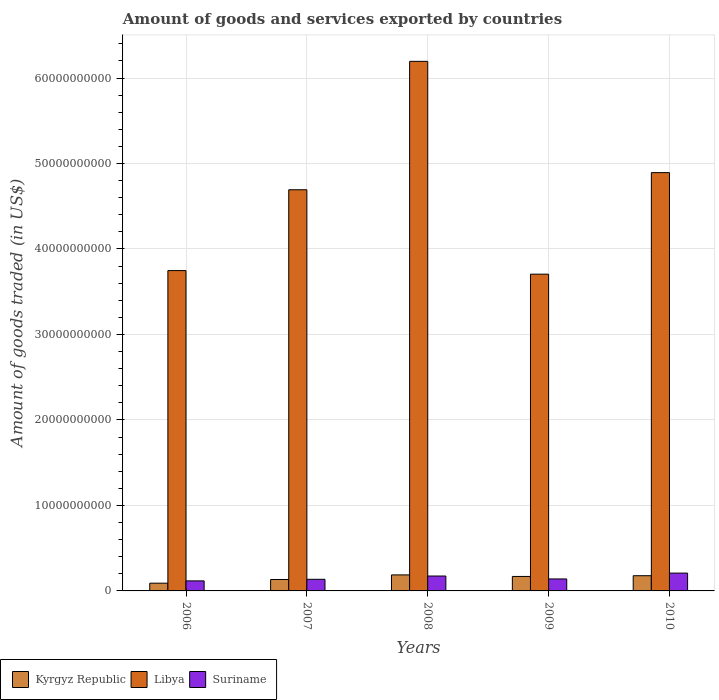How many different coloured bars are there?
Offer a terse response. 3. How many bars are there on the 5th tick from the left?
Make the answer very short. 3. How many bars are there on the 1st tick from the right?
Offer a very short reply. 3. What is the total amount of goods and services exported in Kyrgyz Republic in 2009?
Ensure brevity in your answer.  1.69e+09. Across all years, what is the maximum total amount of goods and services exported in Kyrgyz Republic?
Your answer should be very brief. 1.87e+09. Across all years, what is the minimum total amount of goods and services exported in Suriname?
Your answer should be compact. 1.17e+09. In which year was the total amount of goods and services exported in Suriname maximum?
Provide a succinct answer. 2010. In which year was the total amount of goods and services exported in Kyrgyz Republic minimum?
Make the answer very short. 2006. What is the total total amount of goods and services exported in Libya in the graph?
Make the answer very short. 2.32e+11. What is the difference between the total amount of goods and services exported in Kyrgyz Republic in 2006 and that in 2009?
Give a very brief answer. -7.88e+08. What is the difference between the total amount of goods and services exported in Libya in 2008 and the total amount of goods and services exported in Suriname in 2010?
Your answer should be very brief. 5.99e+1. What is the average total amount of goods and services exported in Kyrgyz Republic per year?
Your answer should be compact. 1.52e+09. In the year 2009, what is the difference between the total amount of goods and services exported in Kyrgyz Republic and total amount of goods and services exported in Suriname?
Keep it short and to the point. 2.92e+08. What is the ratio of the total amount of goods and services exported in Kyrgyz Republic in 2006 to that in 2007?
Offer a terse response. 0.68. Is the difference between the total amount of goods and services exported in Kyrgyz Republic in 2008 and 2010 greater than the difference between the total amount of goods and services exported in Suriname in 2008 and 2010?
Make the answer very short. Yes. What is the difference between the highest and the second highest total amount of goods and services exported in Kyrgyz Republic?
Your answer should be compact. 9.57e+07. What is the difference between the highest and the lowest total amount of goods and services exported in Suriname?
Give a very brief answer. 9.10e+08. In how many years, is the total amount of goods and services exported in Kyrgyz Republic greater than the average total amount of goods and services exported in Kyrgyz Republic taken over all years?
Offer a terse response. 3. What does the 3rd bar from the left in 2008 represents?
Give a very brief answer. Suriname. What does the 1st bar from the right in 2006 represents?
Offer a very short reply. Suriname. Is it the case that in every year, the sum of the total amount of goods and services exported in Libya and total amount of goods and services exported in Kyrgyz Republic is greater than the total amount of goods and services exported in Suriname?
Your response must be concise. Yes. How many bars are there?
Ensure brevity in your answer.  15. Are all the bars in the graph horizontal?
Make the answer very short. No. What is the difference between two consecutive major ticks on the Y-axis?
Your answer should be very brief. 1.00e+1. Are the values on the major ticks of Y-axis written in scientific E-notation?
Ensure brevity in your answer.  No. Does the graph contain any zero values?
Your response must be concise. No. Does the graph contain grids?
Provide a succinct answer. Yes. Where does the legend appear in the graph?
Your response must be concise. Bottom left. How many legend labels are there?
Provide a short and direct response. 3. How are the legend labels stacked?
Provide a short and direct response. Horizontal. What is the title of the graph?
Your answer should be compact. Amount of goods and services exported by countries. What is the label or title of the Y-axis?
Your answer should be compact. Amount of goods traded (in US$). What is the Amount of goods traded (in US$) of Kyrgyz Republic in 2006?
Offer a terse response. 9.06e+08. What is the Amount of goods traded (in US$) in Libya in 2006?
Offer a terse response. 3.75e+1. What is the Amount of goods traded (in US$) in Suriname in 2006?
Make the answer very short. 1.17e+09. What is the Amount of goods traded (in US$) in Kyrgyz Republic in 2007?
Give a very brief answer. 1.34e+09. What is the Amount of goods traded (in US$) in Libya in 2007?
Your response must be concise. 4.69e+1. What is the Amount of goods traded (in US$) of Suriname in 2007?
Provide a short and direct response. 1.36e+09. What is the Amount of goods traded (in US$) of Kyrgyz Republic in 2008?
Keep it short and to the point. 1.87e+09. What is the Amount of goods traded (in US$) of Libya in 2008?
Your answer should be very brief. 6.20e+1. What is the Amount of goods traded (in US$) of Suriname in 2008?
Your answer should be compact. 1.74e+09. What is the Amount of goods traded (in US$) of Kyrgyz Republic in 2009?
Offer a very short reply. 1.69e+09. What is the Amount of goods traded (in US$) in Libya in 2009?
Make the answer very short. 3.71e+1. What is the Amount of goods traded (in US$) in Suriname in 2009?
Offer a very short reply. 1.40e+09. What is the Amount of goods traded (in US$) in Kyrgyz Republic in 2010?
Ensure brevity in your answer.  1.78e+09. What is the Amount of goods traded (in US$) in Libya in 2010?
Your answer should be very brief. 4.89e+1. What is the Amount of goods traded (in US$) in Suriname in 2010?
Provide a succinct answer. 2.08e+09. Across all years, what is the maximum Amount of goods traded (in US$) in Kyrgyz Republic?
Ensure brevity in your answer.  1.87e+09. Across all years, what is the maximum Amount of goods traded (in US$) of Libya?
Give a very brief answer. 6.20e+1. Across all years, what is the maximum Amount of goods traded (in US$) in Suriname?
Provide a short and direct response. 2.08e+09. Across all years, what is the minimum Amount of goods traded (in US$) of Kyrgyz Republic?
Provide a short and direct response. 9.06e+08. Across all years, what is the minimum Amount of goods traded (in US$) in Libya?
Make the answer very short. 3.71e+1. Across all years, what is the minimum Amount of goods traded (in US$) in Suriname?
Provide a short and direct response. 1.17e+09. What is the total Amount of goods traded (in US$) of Kyrgyz Republic in the graph?
Make the answer very short. 7.59e+09. What is the total Amount of goods traded (in US$) of Libya in the graph?
Give a very brief answer. 2.32e+11. What is the total Amount of goods traded (in US$) of Suriname in the graph?
Offer a very short reply. 7.76e+09. What is the difference between the Amount of goods traded (in US$) of Kyrgyz Republic in 2006 and that in 2007?
Offer a terse response. -4.32e+08. What is the difference between the Amount of goods traded (in US$) in Libya in 2006 and that in 2007?
Offer a very short reply. -9.46e+09. What is the difference between the Amount of goods traded (in US$) in Suriname in 2006 and that in 2007?
Provide a short and direct response. -1.84e+08. What is the difference between the Amount of goods traded (in US$) in Kyrgyz Republic in 2006 and that in 2008?
Offer a terse response. -9.68e+08. What is the difference between the Amount of goods traded (in US$) of Libya in 2006 and that in 2008?
Make the answer very short. -2.45e+1. What is the difference between the Amount of goods traded (in US$) of Suriname in 2006 and that in 2008?
Keep it short and to the point. -5.69e+08. What is the difference between the Amount of goods traded (in US$) of Kyrgyz Republic in 2006 and that in 2009?
Your answer should be compact. -7.88e+08. What is the difference between the Amount of goods traded (in US$) of Libya in 2006 and that in 2009?
Your answer should be compact. 4.18e+08. What is the difference between the Amount of goods traded (in US$) of Suriname in 2006 and that in 2009?
Provide a short and direct response. -2.27e+08. What is the difference between the Amount of goods traded (in US$) in Kyrgyz Republic in 2006 and that in 2010?
Your answer should be compact. -8.73e+08. What is the difference between the Amount of goods traded (in US$) of Libya in 2006 and that in 2010?
Give a very brief answer. -1.15e+1. What is the difference between the Amount of goods traded (in US$) in Suriname in 2006 and that in 2010?
Ensure brevity in your answer.  -9.10e+08. What is the difference between the Amount of goods traded (in US$) of Kyrgyz Republic in 2007 and that in 2008?
Offer a very short reply. -5.37e+08. What is the difference between the Amount of goods traded (in US$) in Libya in 2007 and that in 2008?
Offer a very short reply. -1.50e+1. What is the difference between the Amount of goods traded (in US$) of Suriname in 2007 and that in 2008?
Give a very brief answer. -3.84e+08. What is the difference between the Amount of goods traded (in US$) of Kyrgyz Republic in 2007 and that in 2009?
Offer a terse response. -3.56e+08. What is the difference between the Amount of goods traded (in US$) in Libya in 2007 and that in 2009?
Give a very brief answer. 9.87e+09. What is the difference between the Amount of goods traded (in US$) of Suriname in 2007 and that in 2009?
Give a very brief answer. -4.28e+07. What is the difference between the Amount of goods traded (in US$) in Kyrgyz Republic in 2007 and that in 2010?
Offer a terse response. -4.41e+08. What is the difference between the Amount of goods traded (in US$) of Libya in 2007 and that in 2010?
Ensure brevity in your answer.  -2.01e+09. What is the difference between the Amount of goods traded (in US$) of Suriname in 2007 and that in 2010?
Provide a short and direct response. -7.25e+08. What is the difference between the Amount of goods traded (in US$) in Kyrgyz Republic in 2008 and that in 2009?
Make the answer very short. 1.81e+08. What is the difference between the Amount of goods traded (in US$) of Libya in 2008 and that in 2009?
Give a very brief answer. 2.49e+1. What is the difference between the Amount of goods traded (in US$) of Suriname in 2008 and that in 2009?
Your answer should be compact. 3.42e+08. What is the difference between the Amount of goods traded (in US$) of Kyrgyz Republic in 2008 and that in 2010?
Provide a short and direct response. 9.57e+07. What is the difference between the Amount of goods traded (in US$) in Libya in 2008 and that in 2010?
Offer a very short reply. 1.30e+1. What is the difference between the Amount of goods traded (in US$) of Suriname in 2008 and that in 2010?
Your answer should be very brief. -3.41e+08. What is the difference between the Amount of goods traded (in US$) in Kyrgyz Republic in 2009 and that in 2010?
Provide a short and direct response. -8.49e+07. What is the difference between the Amount of goods traded (in US$) of Libya in 2009 and that in 2010?
Provide a succinct answer. -1.19e+1. What is the difference between the Amount of goods traded (in US$) in Suriname in 2009 and that in 2010?
Provide a succinct answer. -6.82e+08. What is the difference between the Amount of goods traded (in US$) in Kyrgyz Republic in 2006 and the Amount of goods traded (in US$) in Libya in 2007?
Make the answer very short. -4.60e+1. What is the difference between the Amount of goods traded (in US$) of Kyrgyz Republic in 2006 and the Amount of goods traded (in US$) of Suriname in 2007?
Make the answer very short. -4.53e+08. What is the difference between the Amount of goods traded (in US$) of Libya in 2006 and the Amount of goods traded (in US$) of Suriname in 2007?
Provide a succinct answer. 3.61e+1. What is the difference between the Amount of goods traded (in US$) of Kyrgyz Republic in 2006 and the Amount of goods traded (in US$) of Libya in 2008?
Ensure brevity in your answer.  -6.10e+1. What is the difference between the Amount of goods traded (in US$) of Kyrgyz Republic in 2006 and the Amount of goods traded (in US$) of Suriname in 2008?
Provide a short and direct response. -8.38e+08. What is the difference between the Amount of goods traded (in US$) of Libya in 2006 and the Amount of goods traded (in US$) of Suriname in 2008?
Keep it short and to the point. 3.57e+1. What is the difference between the Amount of goods traded (in US$) of Kyrgyz Republic in 2006 and the Amount of goods traded (in US$) of Libya in 2009?
Keep it short and to the point. -3.61e+1. What is the difference between the Amount of goods traded (in US$) of Kyrgyz Republic in 2006 and the Amount of goods traded (in US$) of Suriname in 2009?
Make the answer very short. -4.96e+08. What is the difference between the Amount of goods traded (in US$) in Libya in 2006 and the Amount of goods traded (in US$) in Suriname in 2009?
Make the answer very short. 3.61e+1. What is the difference between the Amount of goods traded (in US$) of Kyrgyz Republic in 2006 and the Amount of goods traded (in US$) of Libya in 2010?
Ensure brevity in your answer.  -4.80e+1. What is the difference between the Amount of goods traded (in US$) of Kyrgyz Republic in 2006 and the Amount of goods traded (in US$) of Suriname in 2010?
Provide a short and direct response. -1.18e+09. What is the difference between the Amount of goods traded (in US$) of Libya in 2006 and the Amount of goods traded (in US$) of Suriname in 2010?
Provide a short and direct response. 3.54e+1. What is the difference between the Amount of goods traded (in US$) in Kyrgyz Republic in 2007 and the Amount of goods traded (in US$) in Libya in 2008?
Make the answer very short. -6.06e+1. What is the difference between the Amount of goods traded (in US$) of Kyrgyz Republic in 2007 and the Amount of goods traded (in US$) of Suriname in 2008?
Your answer should be compact. -4.06e+08. What is the difference between the Amount of goods traded (in US$) in Libya in 2007 and the Amount of goods traded (in US$) in Suriname in 2008?
Make the answer very short. 4.52e+1. What is the difference between the Amount of goods traded (in US$) of Kyrgyz Republic in 2007 and the Amount of goods traded (in US$) of Libya in 2009?
Your answer should be very brief. -3.57e+1. What is the difference between the Amount of goods traded (in US$) in Kyrgyz Republic in 2007 and the Amount of goods traded (in US$) in Suriname in 2009?
Ensure brevity in your answer.  -6.40e+07. What is the difference between the Amount of goods traded (in US$) of Libya in 2007 and the Amount of goods traded (in US$) of Suriname in 2009?
Provide a succinct answer. 4.55e+1. What is the difference between the Amount of goods traded (in US$) of Kyrgyz Republic in 2007 and the Amount of goods traded (in US$) of Libya in 2010?
Your answer should be compact. -4.76e+1. What is the difference between the Amount of goods traded (in US$) of Kyrgyz Republic in 2007 and the Amount of goods traded (in US$) of Suriname in 2010?
Provide a short and direct response. -7.46e+08. What is the difference between the Amount of goods traded (in US$) in Libya in 2007 and the Amount of goods traded (in US$) in Suriname in 2010?
Ensure brevity in your answer.  4.48e+1. What is the difference between the Amount of goods traded (in US$) in Kyrgyz Republic in 2008 and the Amount of goods traded (in US$) in Libya in 2009?
Keep it short and to the point. -3.52e+1. What is the difference between the Amount of goods traded (in US$) in Kyrgyz Republic in 2008 and the Amount of goods traded (in US$) in Suriname in 2009?
Keep it short and to the point. 4.73e+08. What is the difference between the Amount of goods traded (in US$) in Libya in 2008 and the Amount of goods traded (in US$) in Suriname in 2009?
Your answer should be compact. 6.05e+1. What is the difference between the Amount of goods traded (in US$) in Kyrgyz Republic in 2008 and the Amount of goods traded (in US$) in Libya in 2010?
Make the answer very short. -4.71e+1. What is the difference between the Amount of goods traded (in US$) in Kyrgyz Republic in 2008 and the Amount of goods traded (in US$) in Suriname in 2010?
Make the answer very short. -2.10e+08. What is the difference between the Amount of goods traded (in US$) in Libya in 2008 and the Amount of goods traded (in US$) in Suriname in 2010?
Your answer should be compact. 5.99e+1. What is the difference between the Amount of goods traded (in US$) of Kyrgyz Republic in 2009 and the Amount of goods traded (in US$) of Libya in 2010?
Offer a terse response. -4.72e+1. What is the difference between the Amount of goods traded (in US$) of Kyrgyz Republic in 2009 and the Amount of goods traded (in US$) of Suriname in 2010?
Offer a terse response. -3.90e+08. What is the difference between the Amount of goods traded (in US$) in Libya in 2009 and the Amount of goods traded (in US$) in Suriname in 2010?
Your answer should be compact. 3.50e+1. What is the average Amount of goods traded (in US$) in Kyrgyz Republic per year?
Your answer should be very brief. 1.52e+09. What is the average Amount of goods traded (in US$) of Libya per year?
Offer a terse response. 4.65e+1. What is the average Amount of goods traded (in US$) in Suriname per year?
Ensure brevity in your answer.  1.55e+09. In the year 2006, what is the difference between the Amount of goods traded (in US$) in Kyrgyz Republic and Amount of goods traded (in US$) in Libya?
Your answer should be very brief. -3.66e+1. In the year 2006, what is the difference between the Amount of goods traded (in US$) of Kyrgyz Republic and Amount of goods traded (in US$) of Suriname?
Make the answer very short. -2.69e+08. In the year 2006, what is the difference between the Amount of goods traded (in US$) in Libya and Amount of goods traded (in US$) in Suriname?
Give a very brief answer. 3.63e+1. In the year 2007, what is the difference between the Amount of goods traded (in US$) in Kyrgyz Republic and Amount of goods traded (in US$) in Libya?
Provide a short and direct response. -4.56e+1. In the year 2007, what is the difference between the Amount of goods traded (in US$) in Kyrgyz Republic and Amount of goods traded (in US$) in Suriname?
Your answer should be very brief. -2.12e+07. In the year 2007, what is the difference between the Amount of goods traded (in US$) of Libya and Amount of goods traded (in US$) of Suriname?
Provide a succinct answer. 4.56e+1. In the year 2008, what is the difference between the Amount of goods traded (in US$) in Kyrgyz Republic and Amount of goods traded (in US$) in Libya?
Your answer should be compact. -6.01e+1. In the year 2008, what is the difference between the Amount of goods traded (in US$) in Kyrgyz Republic and Amount of goods traded (in US$) in Suriname?
Provide a succinct answer. 1.31e+08. In the year 2008, what is the difference between the Amount of goods traded (in US$) of Libya and Amount of goods traded (in US$) of Suriname?
Your answer should be very brief. 6.02e+1. In the year 2009, what is the difference between the Amount of goods traded (in US$) in Kyrgyz Republic and Amount of goods traded (in US$) in Libya?
Your response must be concise. -3.54e+1. In the year 2009, what is the difference between the Amount of goods traded (in US$) in Kyrgyz Republic and Amount of goods traded (in US$) in Suriname?
Keep it short and to the point. 2.92e+08. In the year 2009, what is the difference between the Amount of goods traded (in US$) of Libya and Amount of goods traded (in US$) of Suriname?
Your answer should be compact. 3.57e+1. In the year 2010, what is the difference between the Amount of goods traded (in US$) in Kyrgyz Republic and Amount of goods traded (in US$) in Libya?
Offer a very short reply. -4.72e+1. In the year 2010, what is the difference between the Amount of goods traded (in US$) in Kyrgyz Republic and Amount of goods traded (in US$) in Suriname?
Your answer should be very brief. -3.05e+08. In the year 2010, what is the difference between the Amount of goods traded (in US$) in Libya and Amount of goods traded (in US$) in Suriname?
Keep it short and to the point. 4.69e+1. What is the ratio of the Amount of goods traded (in US$) of Kyrgyz Republic in 2006 to that in 2007?
Give a very brief answer. 0.68. What is the ratio of the Amount of goods traded (in US$) in Libya in 2006 to that in 2007?
Give a very brief answer. 0.8. What is the ratio of the Amount of goods traded (in US$) in Suriname in 2006 to that in 2007?
Provide a succinct answer. 0.86. What is the ratio of the Amount of goods traded (in US$) of Kyrgyz Republic in 2006 to that in 2008?
Your answer should be very brief. 0.48. What is the ratio of the Amount of goods traded (in US$) in Libya in 2006 to that in 2008?
Your response must be concise. 0.6. What is the ratio of the Amount of goods traded (in US$) of Suriname in 2006 to that in 2008?
Ensure brevity in your answer.  0.67. What is the ratio of the Amount of goods traded (in US$) in Kyrgyz Republic in 2006 to that in 2009?
Keep it short and to the point. 0.53. What is the ratio of the Amount of goods traded (in US$) of Libya in 2006 to that in 2009?
Your answer should be compact. 1.01. What is the ratio of the Amount of goods traded (in US$) of Suriname in 2006 to that in 2009?
Provide a succinct answer. 0.84. What is the ratio of the Amount of goods traded (in US$) of Kyrgyz Republic in 2006 to that in 2010?
Keep it short and to the point. 0.51. What is the ratio of the Amount of goods traded (in US$) of Libya in 2006 to that in 2010?
Your response must be concise. 0.77. What is the ratio of the Amount of goods traded (in US$) of Suriname in 2006 to that in 2010?
Your response must be concise. 0.56. What is the ratio of the Amount of goods traded (in US$) of Kyrgyz Republic in 2007 to that in 2008?
Offer a very short reply. 0.71. What is the ratio of the Amount of goods traded (in US$) in Libya in 2007 to that in 2008?
Offer a very short reply. 0.76. What is the ratio of the Amount of goods traded (in US$) of Suriname in 2007 to that in 2008?
Your answer should be very brief. 0.78. What is the ratio of the Amount of goods traded (in US$) in Kyrgyz Republic in 2007 to that in 2009?
Provide a short and direct response. 0.79. What is the ratio of the Amount of goods traded (in US$) of Libya in 2007 to that in 2009?
Give a very brief answer. 1.27. What is the ratio of the Amount of goods traded (in US$) in Suriname in 2007 to that in 2009?
Offer a very short reply. 0.97. What is the ratio of the Amount of goods traded (in US$) in Kyrgyz Republic in 2007 to that in 2010?
Make the answer very short. 0.75. What is the ratio of the Amount of goods traded (in US$) in Libya in 2007 to that in 2010?
Give a very brief answer. 0.96. What is the ratio of the Amount of goods traded (in US$) of Suriname in 2007 to that in 2010?
Offer a terse response. 0.65. What is the ratio of the Amount of goods traded (in US$) of Kyrgyz Republic in 2008 to that in 2009?
Your response must be concise. 1.11. What is the ratio of the Amount of goods traded (in US$) in Libya in 2008 to that in 2009?
Offer a terse response. 1.67. What is the ratio of the Amount of goods traded (in US$) of Suriname in 2008 to that in 2009?
Your answer should be compact. 1.24. What is the ratio of the Amount of goods traded (in US$) in Kyrgyz Republic in 2008 to that in 2010?
Provide a succinct answer. 1.05. What is the ratio of the Amount of goods traded (in US$) of Libya in 2008 to that in 2010?
Your answer should be compact. 1.27. What is the ratio of the Amount of goods traded (in US$) in Suriname in 2008 to that in 2010?
Provide a succinct answer. 0.84. What is the ratio of the Amount of goods traded (in US$) of Kyrgyz Republic in 2009 to that in 2010?
Your response must be concise. 0.95. What is the ratio of the Amount of goods traded (in US$) in Libya in 2009 to that in 2010?
Provide a succinct answer. 0.76. What is the ratio of the Amount of goods traded (in US$) in Suriname in 2009 to that in 2010?
Your answer should be compact. 0.67. What is the difference between the highest and the second highest Amount of goods traded (in US$) in Kyrgyz Republic?
Keep it short and to the point. 9.57e+07. What is the difference between the highest and the second highest Amount of goods traded (in US$) in Libya?
Offer a terse response. 1.30e+1. What is the difference between the highest and the second highest Amount of goods traded (in US$) in Suriname?
Offer a very short reply. 3.41e+08. What is the difference between the highest and the lowest Amount of goods traded (in US$) of Kyrgyz Republic?
Provide a short and direct response. 9.68e+08. What is the difference between the highest and the lowest Amount of goods traded (in US$) in Libya?
Give a very brief answer. 2.49e+1. What is the difference between the highest and the lowest Amount of goods traded (in US$) in Suriname?
Offer a terse response. 9.10e+08. 